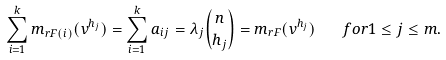<formula> <loc_0><loc_0><loc_500><loc_500>\sum _ { i = 1 } ^ { k } m _ { r F ( i ) } ( v ^ { h _ { j } } ) = \sum _ { i = 1 } ^ { k } a _ { i j } = \lambda _ { j } \binom { n } { h _ { j } } = m _ { r F } ( v ^ { h _ { j } } ) \quad f o r 1 \leq j \leq m .</formula> 